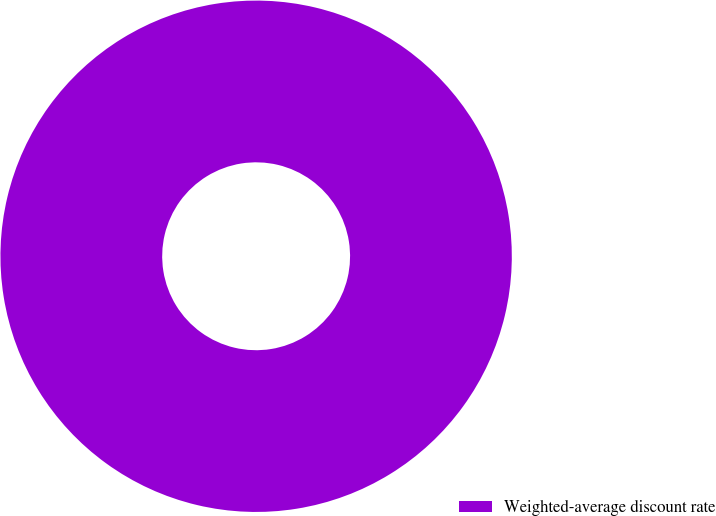Convert chart. <chart><loc_0><loc_0><loc_500><loc_500><pie_chart><fcel>Weighted-average discount rate<nl><fcel>100.0%<nl></chart> 